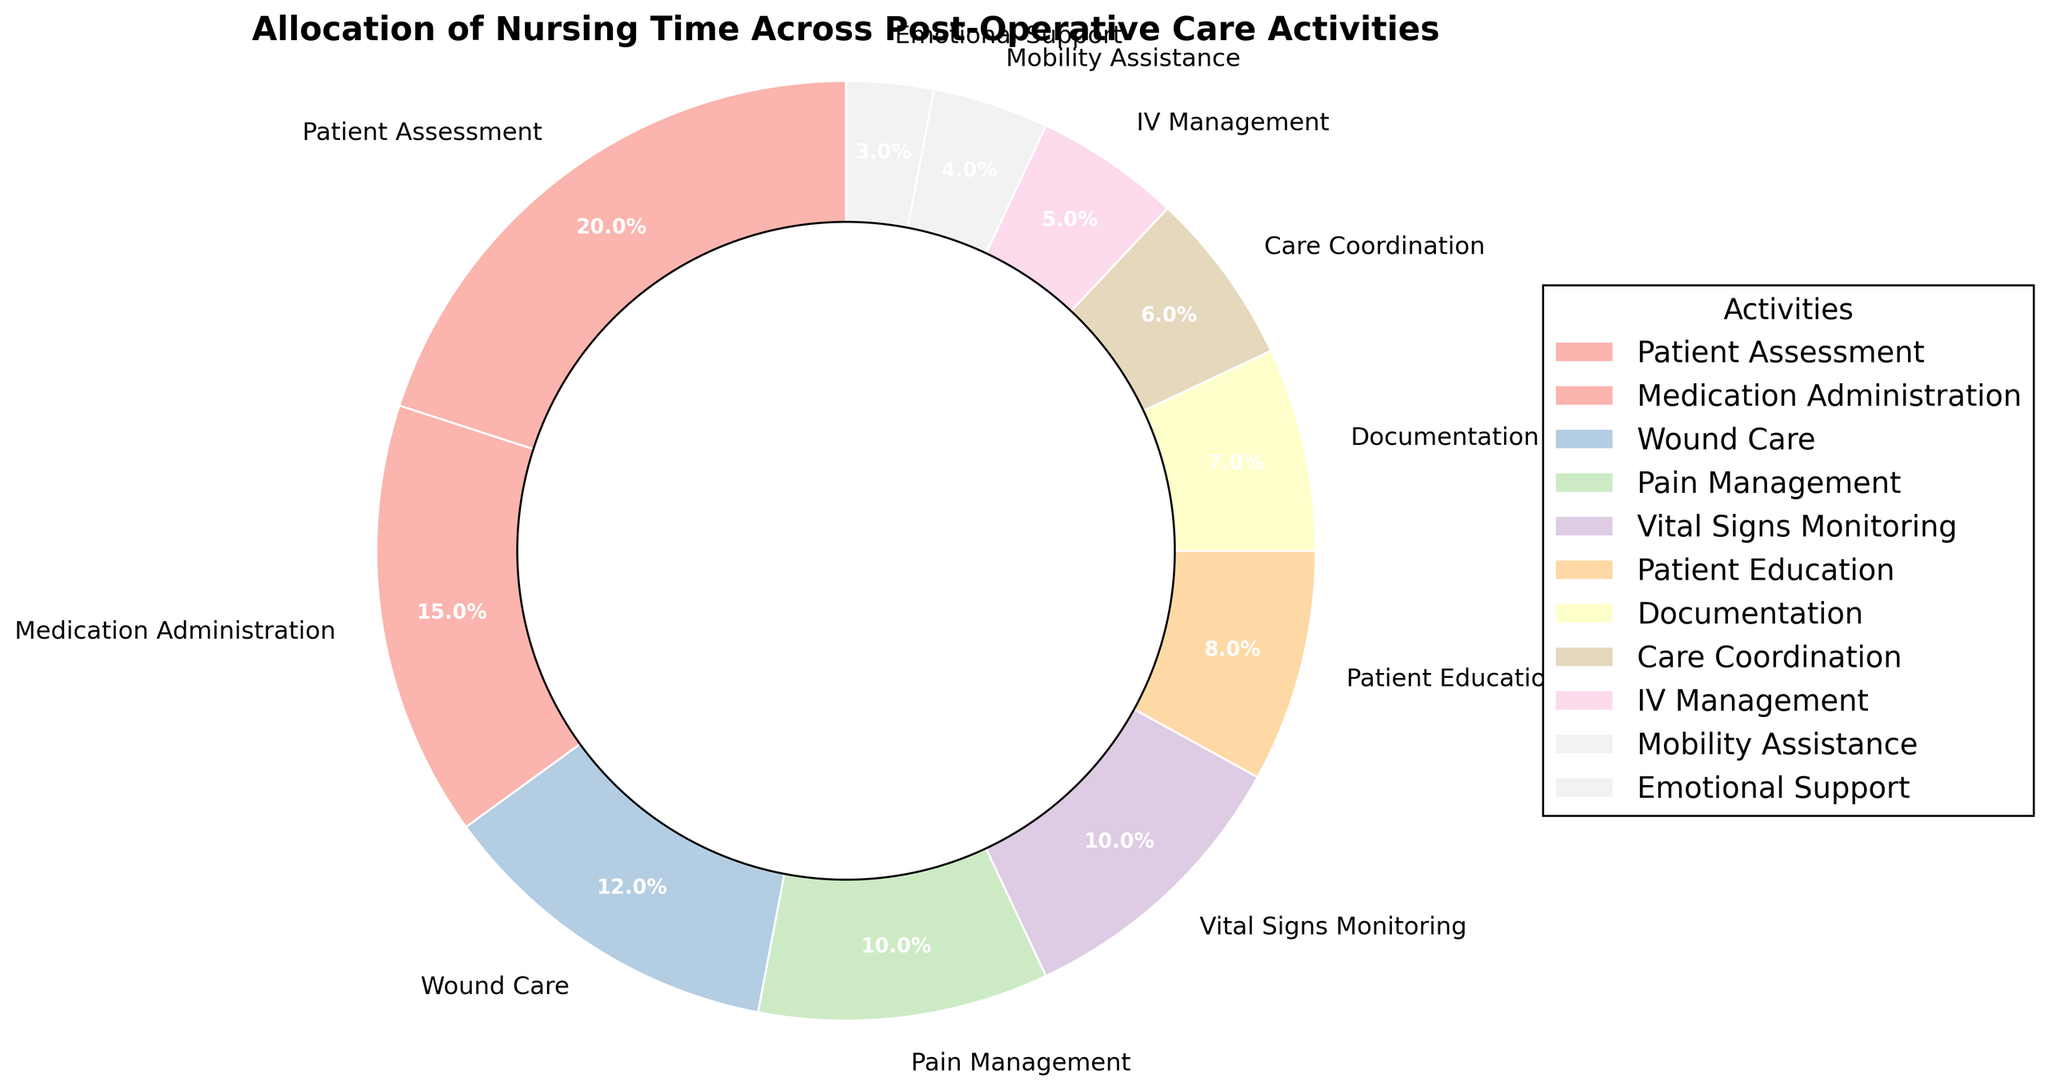Which activity consumes the highest percentage of nursing time? The highest percentage can be found by identifying the largest segment in the pie chart. The segment labeled 'Patient Assessment' occupies the largest portion.
Answer: Patient Assessment How many activities take up 10% or more of the nursing time? By visually examining the pie chart, we can count the segments with percentages labeled as 10% or greater. These are 'Patient Assessment', 'Medication Administration', 'Wound Care', 'Pain Management', and 'Vital Signs Monitoring'.
Answer: 5 What is the total percentage of time spent on 'Pain Management' and 'Vital Signs Monitoring'? Both percentages are shown in the pie chart. Adding them together: 10% (Pain Management) + 10% (Vital Signs Monitoring) = 20%.
Answer: 20% Which two activities combined take up the same percentage of time as 'Patient Assessment'? First, identify the percentage for 'Patient Assessment' (20%). Then find two other activities whose combined percentages sum to 20%. 'Medication Administration' (15%) and 'Emotional Support' (3%) together make 18%, which is less. However, 'Wound Care' (12%) and 'Patient Education' (8%) together make 20%.
Answer: Wound Care and Patient Education What percentage of time is spent on activities labeled as having less than 5%? Identify activities with less than 5% from the chart: 'Mobility Assistance' (4%) and 'Emotional Support' (3%). Summing them up: 4% + 3% = 7%.
Answer: 7% Which activity utilizes the least amount of nursing time? The smallest segment in the pie chart corresponds to 'Emotional Support', labeled as occupying 3% of the time.
Answer: Emotional Support Is more time spent on 'Medication Administration' or 'Wound Care'? Comparing the segments for both activities, 'Medication Administration' shows 15%, while 'Wound Care' shows 12%.
Answer: Medication Administration By how much does the percentage of time spent on 'Care Coordination' exceed that of 'IV Management'? Subtract the percentage for 'IV Management' from 'Care Coordination': 6% (Care Coordination) - 5% (IV Management) = 1%.
Answer: 1% What is the cumulative percentage of time spent on 'Patient Education', 'Documentation', and 'Care Coordination'? Adding the percentages: 8% (Patient Education) + 7% (Documentation) + 6% (Care Coordination) = 21%.
Answer: 21% Which segment has a more pronounced color on the outer ring, 'Vital Signs Monitoring' or 'Pain Management'? Observing the pie chart, determine which segment appears more visually prominent. Both segments share the same percentage, hence the color distinction is more subjective, but considering visual perception, one may note that 'Pain Management' and 'Vital Signs Monitoring' both have similar presence.
Answer: Both appear similarly prominent 